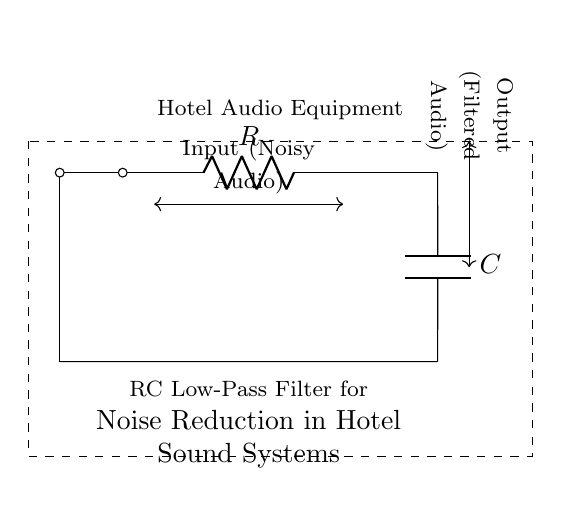What are the components in the circuit? The circuit consists of a resistor and a capacitor, which are the primary components of an RC low-pass filter.
Answer: Resistor and Capacitor What is the type of filter represented in this circuit? The circuit diagram shows an RC low-pass filter designed to allow low-frequency signals to pass while attenuating higher-frequency noise.
Answer: Low-pass filter What is the purpose of this circuit? The purpose of the RC filter is to reduce noise in the audio signal, enhancing the quality of sound during film recording in hotel sound systems.
Answer: Noise reduction What is the input signal specification? The input signal to the circuit is indicated as noisy audio, which is the sound input that needs filtering.
Answer: Noisy Audio At what point can we expect the filtered audio output? The filtered audio output can be expected at the end of the capacitor, as it connects the capacitor to the output terminal.
Answer: After the capacitor What happens to high-frequency noise in this circuit? High-frequency noise is attenuated by the RC filter, meaning it is reduced in amplitude and thus becomes less prominent in the output audio.
Answer: Attenuated What does the dashed rectangle in the diagram represent? The dashed rectangle represents the boundaries of the hotel audio equipment that is utilizing the RC filter, enclosing the essential components.
Answer: Hotel Audio Equipment 